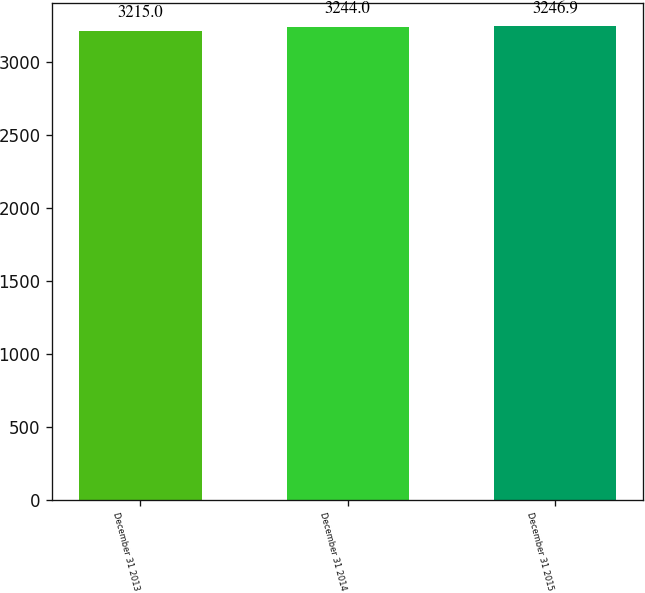<chart> <loc_0><loc_0><loc_500><loc_500><bar_chart><fcel>December 31 2013<fcel>December 31 2014<fcel>December 31 2015<nl><fcel>3215<fcel>3244<fcel>3246.9<nl></chart> 